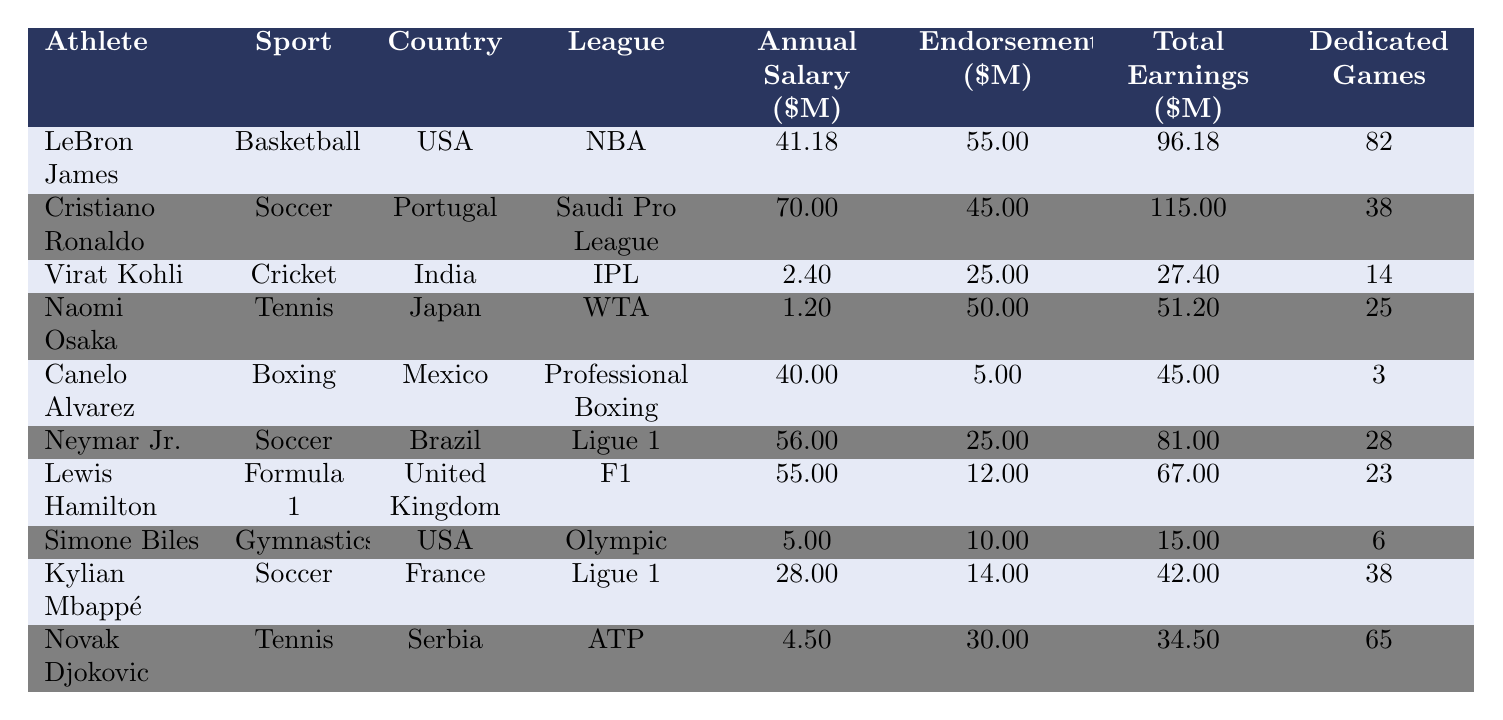What is the annual salary of LeBron James? The table shows that LeBron James has an annual salary of 41.18 million dollars.
Answer: 41.18 million dollars Which athlete has the highest total earnings? By comparing the total earnings of all athletes listed, Cristiano Ronaldo has the highest total earnings at 115 million dollars.
Answer: Cristiano Ronaldo How many dedicated games did Naomi Osaka play? According to the table, Naomi Osaka played 25 dedicated games.
Answer: 25 What is the total earnings of Neymar Jr.? The total earnings for Neymar Jr. are listed as 81 million dollars.
Answer: 81 million dollars Which sport has the highest average annual salary? To find this, we calculate the annual salaries: Basketball (41.18), Soccer (70 and 56), Cricket (2.40), Tennis (1.20), Boxing (40), Formula 1 (55), Gymnastics (5), and the average for Soccer players (Cristiano Ronaldo and Neymar) is (70 + 56) / 2 = 63 million dollars, which is the highest average annual salary.
Answer: Soccer Is Virat Kohli's salary higher than that of Naomi Osaka? Virat Kohli's annual salary is 2.40 million dollars while Naomi Osaka's is 1.20 million dollars, so Virat Kohli’s salary is higher.
Answer: Yes What is the difference in total earnings between LeBron James and Canelo Alvarez? LeBron James has total earnings of 96.18 million dollars and Canelo Alvarez has 45 million dollars. The difference is 96.18 - 45 = 51.18 million dollars.
Answer: 51.18 million dollars Which athlete has the most endorsements? From the table, LeBron James has the most endorsements at 55 million dollars.
Answer: LeBron James What is the average number of dedicated games played by athletes in the table? The total number of dedicated games is (82 + 38 + 14 + 25 + 3 + 28 + 23 + 6 + 38 + 65) = 322 games, and there are 10 athletes, so the average is 322 / 10 = 32.2 games.
Answer: 32.2 games Does any athlete earn more from endorsements than from their annual salary? Yes, both Naomi Osaka and Cristiano Ronaldo earn more from endorsements (50 million and 45 million, respectively) compared to their annual salaries (1.20 million and 70 million).
Answer: Yes 